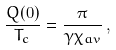<formula> <loc_0><loc_0><loc_500><loc_500>\frac { Q ( 0 ) } { T _ { c } } = \frac { \pi } { \gamma \chi _ { a v } } \, ,</formula> 